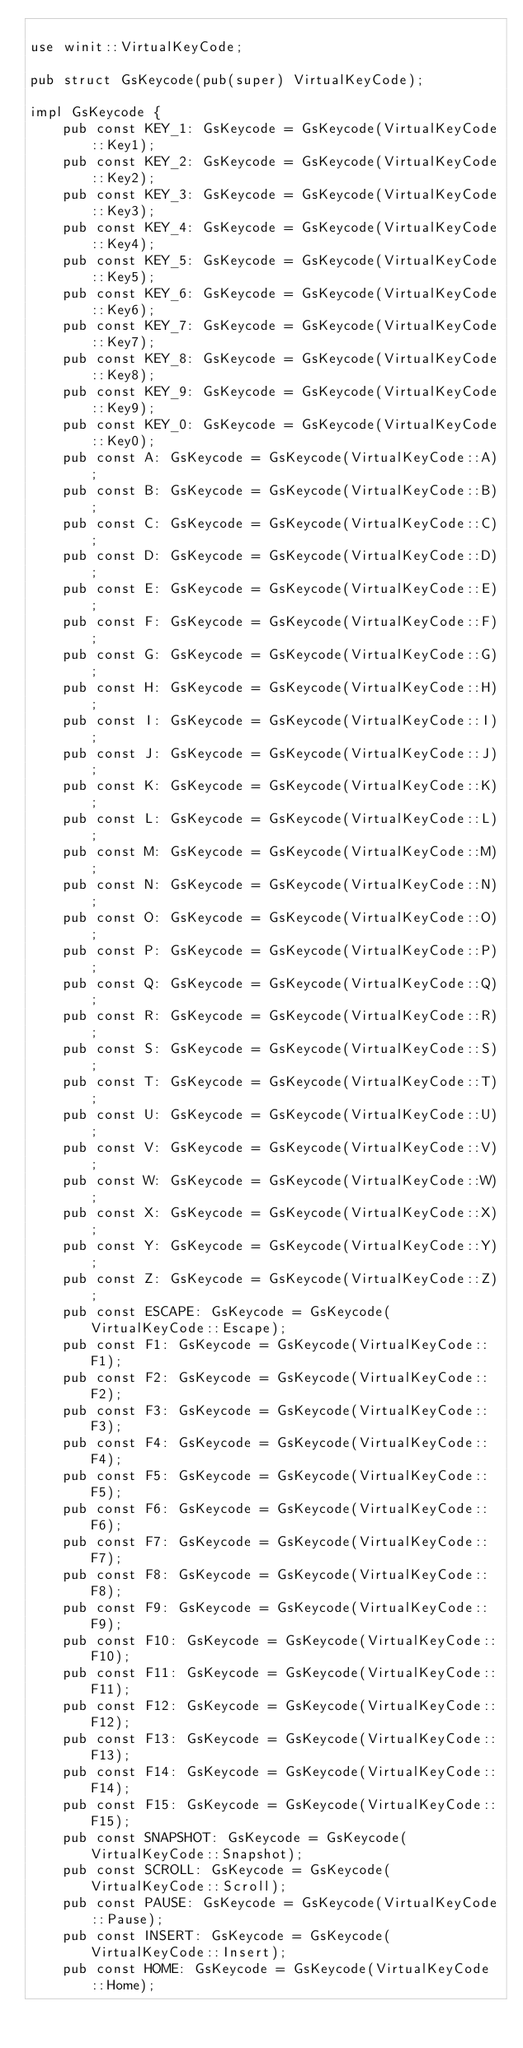<code> <loc_0><loc_0><loc_500><loc_500><_Rust_>
use winit::VirtualKeyCode;

pub struct GsKeycode(pub(super) VirtualKeyCode);

impl GsKeycode {
    pub const KEY_1: GsKeycode = GsKeycode(VirtualKeyCode::Key1);
    pub const KEY_2: GsKeycode = GsKeycode(VirtualKeyCode::Key2);
    pub const KEY_3: GsKeycode = GsKeycode(VirtualKeyCode::Key3);
    pub const KEY_4: GsKeycode = GsKeycode(VirtualKeyCode::Key4);
    pub const KEY_5: GsKeycode = GsKeycode(VirtualKeyCode::Key5);
    pub const KEY_6: GsKeycode = GsKeycode(VirtualKeyCode::Key6);
    pub const KEY_7: GsKeycode = GsKeycode(VirtualKeyCode::Key7);
    pub const KEY_8: GsKeycode = GsKeycode(VirtualKeyCode::Key8);
    pub const KEY_9: GsKeycode = GsKeycode(VirtualKeyCode::Key9);
    pub const KEY_0: GsKeycode = GsKeycode(VirtualKeyCode::Key0);
    pub const A: GsKeycode = GsKeycode(VirtualKeyCode::A);
    pub const B: GsKeycode = GsKeycode(VirtualKeyCode::B);
    pub const C: GsKeycode = GsKeycode(VirtualKeyCode::C);
    pub const D: GsKeycode = GsKeycode(VirtualKeyCode::D);
    pub const E: GsKeycode = GsKeycode(VirtualKeyCode::E);
    pub const F: GsKeycode = GsKeycode(VirtualKeyCode::F);
    pub const G: GsKeycode = GsKeycode(VirtualKeyCode::G);
    pub const H: GsKeycode = GsKeycode(VirtualKeyCode::H);
    pub const I: GsKeycode = GsKeycode(VirtualKeyCode::I);
    pub const J: GsKeycode = GsKeycode(VirtualKeyCode::J);
    pub const K: GsKeycode = GsKeycode(VirtualKeyCode::K);
    pub const L: GsKeycode = GsKeycode(VirtualKeyCode::L);
    pub const M: GsKeycode = GsKeycode(VirtualKeyCode::M);
    pub const N: GsKeycode = GsKeycode(VirtualKeyCode::N);
    pub const O: GsKeycode = GsKeycode(VirtualKeyCode::O);
    pub const P: GsKeycode = GsKeycode(VirtualKeyCode::P);
    pub const Q: GsKeycode = GsKeycode(VirtualKeyCode::Q);
    pub const R: GsKeycode = GsKeycode(VirtualKeyCode::R);
    pub const S: GsKeycode = GsKeycode(VirtualKeyCode::S);
    pub const T: GsKeycode = GsKeycode(VirtualKeyCode::T);
    pub const U: GsKeycode = GsKeycode(VirtualKeyCode::U);
    pub const V: GsKeycode = GsKeycode(VirtualKeyCode::V);
    pub const W: GsKeycode = GsKeycode(VirtualKeyCode::W);
    pub const X: GsKeycode = GsKeycode(VirtualKeyCode::X);
    pub const Y: GsKeycode = GsKeycode(VirtualKeyCode::Y);
    pub const Z: GsKeycode = GsKeycode(VirtualKeyCode::Z);
    pub const ESCAPE: GsKeycode = GsKeycode(VirtualKeyCode::Escape);
    pub const F1: GsKeycode = GsKeycode(VirtualKeyCode::F1);
    pub const F2: GsKeycode = GsKeycode(VirtualKeyCode::F2);
    pub const F3: GsKeycode = GsKeycode(VirtualKeyCode::F3);
    pub const F4: GsKeycode = GsKeycode(VirtualKeyCode::F4);
    pub const F5: GsKeycode = GsKeycode(VirtualKeyCode::F5);
    pub const F6: GsKeycode = GsKeycode(VirtualKeyCode::F6);
    pub const F7: GsKeycode = GsKeycode(VirtualKeyCode::F7);
    pub const F8: GsKeycode = GsKeycode(VirtualKeyCode::F8);
    pub const F9: GsKeycode = GsKeycode(VirtualKeyCode::F9);
    pub const F10: GsKeycode = GsKeycode(VirtualKeyCode::F10);
    pub const F11: GsKeycode = GsKeycode(VirtualKeyCode::F11);
    pub const F12: GsKeycode = GsKeycode(VirtualKeyCode::F12);
    pub const F13: GsKeycode = GsKeycode(VirtualKeyCode::F13);
    pub const F14: GsKeycode = GsKeycode(VirtualKeyCode::F14);
    pub const F15: GsKeycode = GsKeycode(VirtualKeyCode::F15);
    pub const SNAPSHOT: GsKeycode = GsKeycode(VirtualKeyCode::Snapshot);
    pub const SCROLL: GsKeycode = GsKeycode(VirtualKeyCode::Scroll);
    pub const PAUSE: GsKeycode = GsKeycode(VirtualKeyCode::Pause);
    pub const INSERT: GsKeycode = GsKeycode(VirtualKeyCode::Insert);
    pub const HOME: GsKeycode = GsKeycode(VirtualKeyCode::Home);</code> 